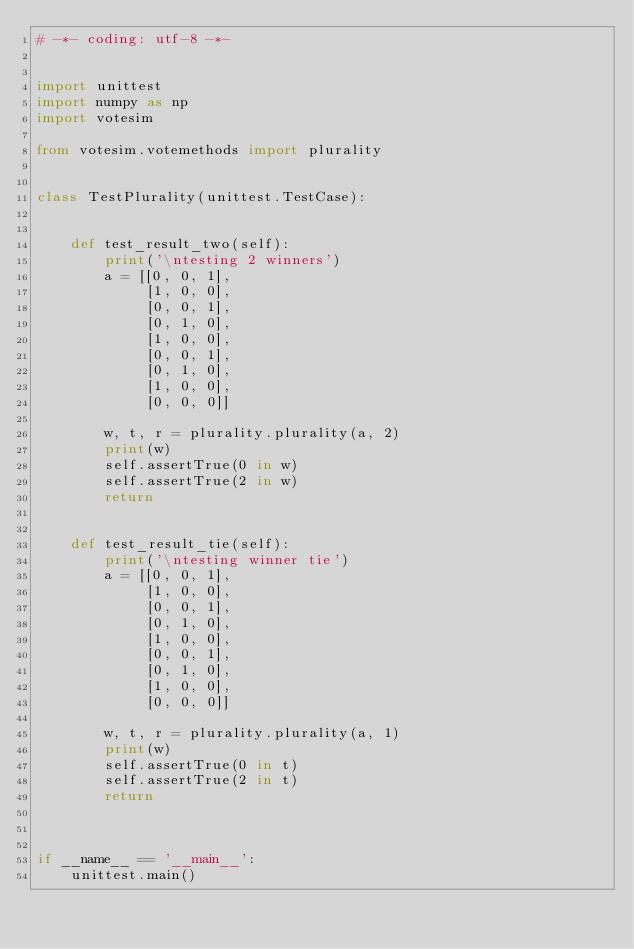Convert code to text. <code><loc_0><loc_0><loc_500><loc_500><_Python_># -*- coding: utf-8 -*-


import unittest
import numpy as np
import votesim

from votesim.votemethods import plurality


class TestPlurality(unittest.TestCase):
    
    
    def test_result_two(self):
        print('\ntesting 2 winners')
        a = [[0, 0, 1],
             [1, 0, 0],
             [0, 0, 1],
             [0, 1, 0],
             [1, 0, 0],
             [0, 0, 1],
             [0, 1, 0],
             [1, 0, 0],
             [0, 0, 0]]
    
        w, t, r = plurality.plurality(a, 2)
        print(w)
        self.assertTrue(0 in w)
        self.assertTrue(2 in w)
        return 
    
    
    def test_result_tie(self):
        print('\ntesting winner tie')
        a = [[0, 0, 1],
             [1, 0, 0],
             [0, 0, 1],
             [0, 1, 0],
             [1, 0, 0],
             [0, 0, 1],
             [0, 1, 0],
             [1, 0, 0],
             [0, 0, 0]]
    
        w, t, r = plurality.plurality(a, 1)
        print(w)
        self.assertTrue(0 in t)
        self.assertTrue(2 in t)
        return     
    
    
    
if __name__ == '__main__':
    unittest.main()
    </code> 